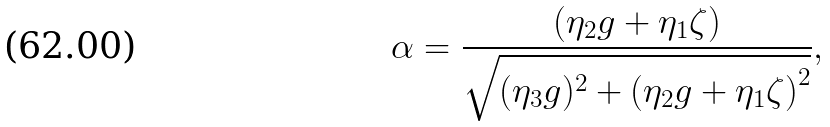<formula> <loc_0><loc_0><loc_500><loc_500>\alpha = \frac { \left ( \eta _ { 2 } g + \eta _ { 1 } \zeta \right ) } { \sqrt { ( \eta _ { 3 } g ) ^ { 2 } + \left ( \eta _ { 2 } g + \eta _ { 1 } \zeta \right ) ^ { 2 } } } ,</formula> 